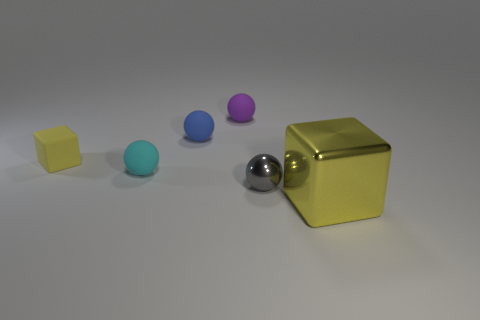Subtract 1 balls. How many balls are left? 3 Add 2 green objects. How many objects exist? 8 Subtract all cubes. How many objects are left? 4 Subtract all large brown shiny cylinders. Subtract all small metallic spheres. How many objects are left? 5 Add 5 yellow metal cubes. How many yellow metal cubes are left? 6 Add 6 big cyan objects. How many big cyan objects exist? 6 Subtract 0 gray cylinders. How many objects are left? 6 